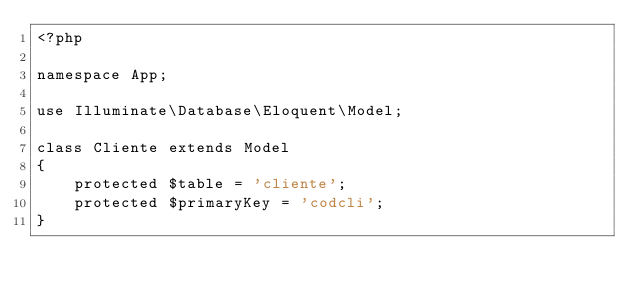Convert code to text. <code><loc_0><loc_0><loc_500><loc_500><_PHP_><?php

namespace App;

use Illuminate\Database\Eloquent\Model;

class Cliente extends Model
{
    protected $table = 'cliente';
    protected $primaryKey = 'codcli';
}
</code> 